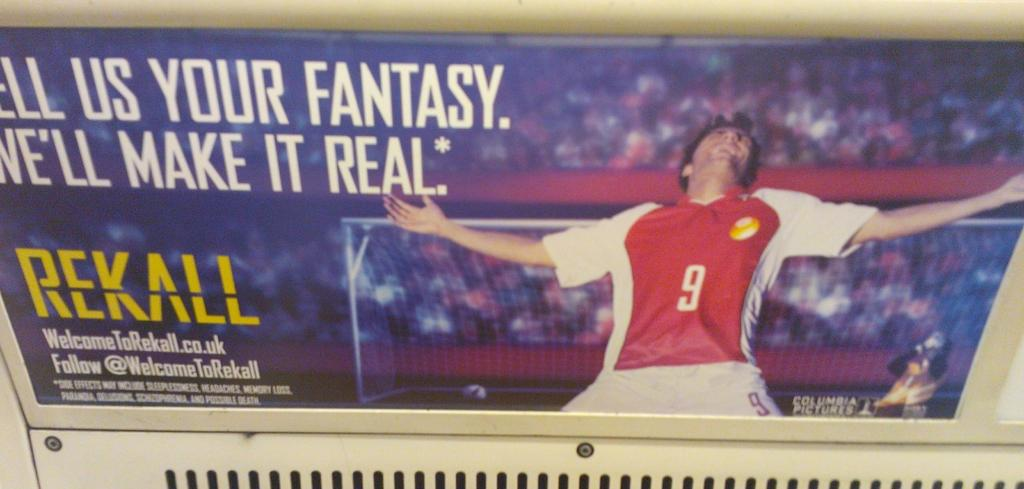<image>
Present a compact description of the photo's key features. An advertisement for a soccer club with the website WelcomeToRekall.co.uk. 